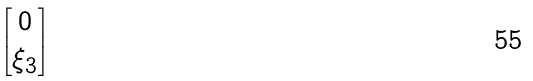Convert formula to latex. <formula><loc_0><loc_0><loc_500><loc_500>\begin{bmatrix} 0 \\ \xi _ { 3 } \end{bmatrix}</formula> 